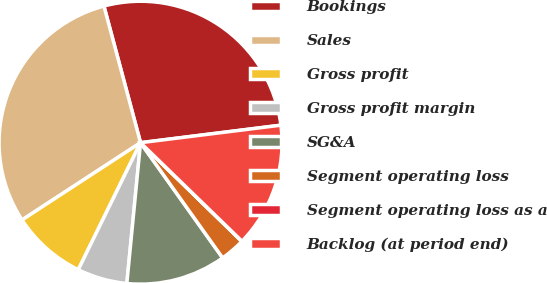<chart> <loc_0><loc_0><loc_500><loc_500><pie_chart><fcel>Bookings<fcel>Sales<fcel>Gross profit<fcel>Gross profit margin<fcel>SG&A<fcel>Segment operating loss<fcel>Segment operating loss as a<fcel>Backlog (at period end)<nl><fcel>27.19%<fcel>30.03%<fcel>8.55%<fcel>5.71%<fcel>11.4%<fcel>2.86%<fcel>0.02%<fcel>14.24%<nl></chart> 